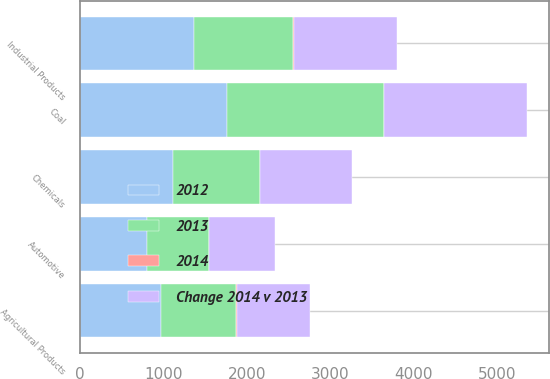Convert chart. <chart><loc_0><loc_0><loc_500><loc_500><stacked_bar_chart><ecel><fcel>Agricultural Products<fcel>Automotive<fcel>Chemicals<fcel>Coal<fcel>Industrial Products<nl><fcel>2012<fcel>973<fcel>809<fcel>1116<fcel>1768<fcel>1368<nl><fcel>Change 2014 v 2013<fcel>874<fcel>781<fcel>1103<fcel>1703<fcel>1236<nl><fcel>2013<fcel>900<fcel>738<fcel>1042<fcel>1871<fcel>1185<nl><fcel>2014<fcel>11<fcel>4<fcel>1<fcel>4<fcel>11<nl></chart> 